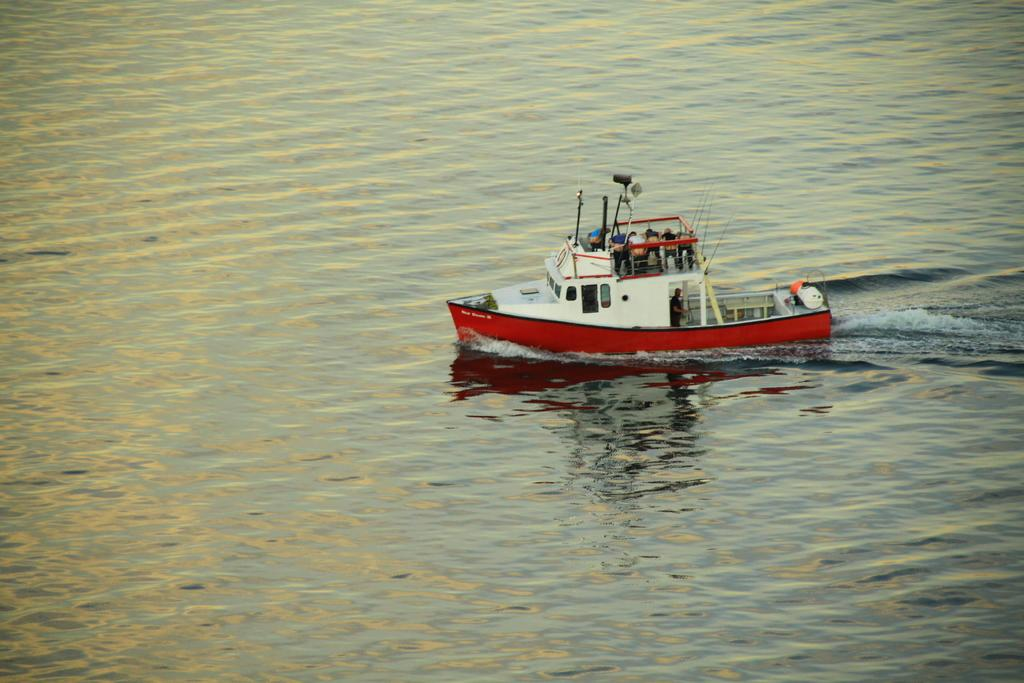What is the main subject of the image? The main subject of the image is a ship. Where is the ship located? The ship is on the water. Are there any people on the ship? Yes, there are people present on the ship. What type of bears can be seen driving the ship in the image? There are no bears present in the image, nor are there any vehicles or driving activities depicted. 